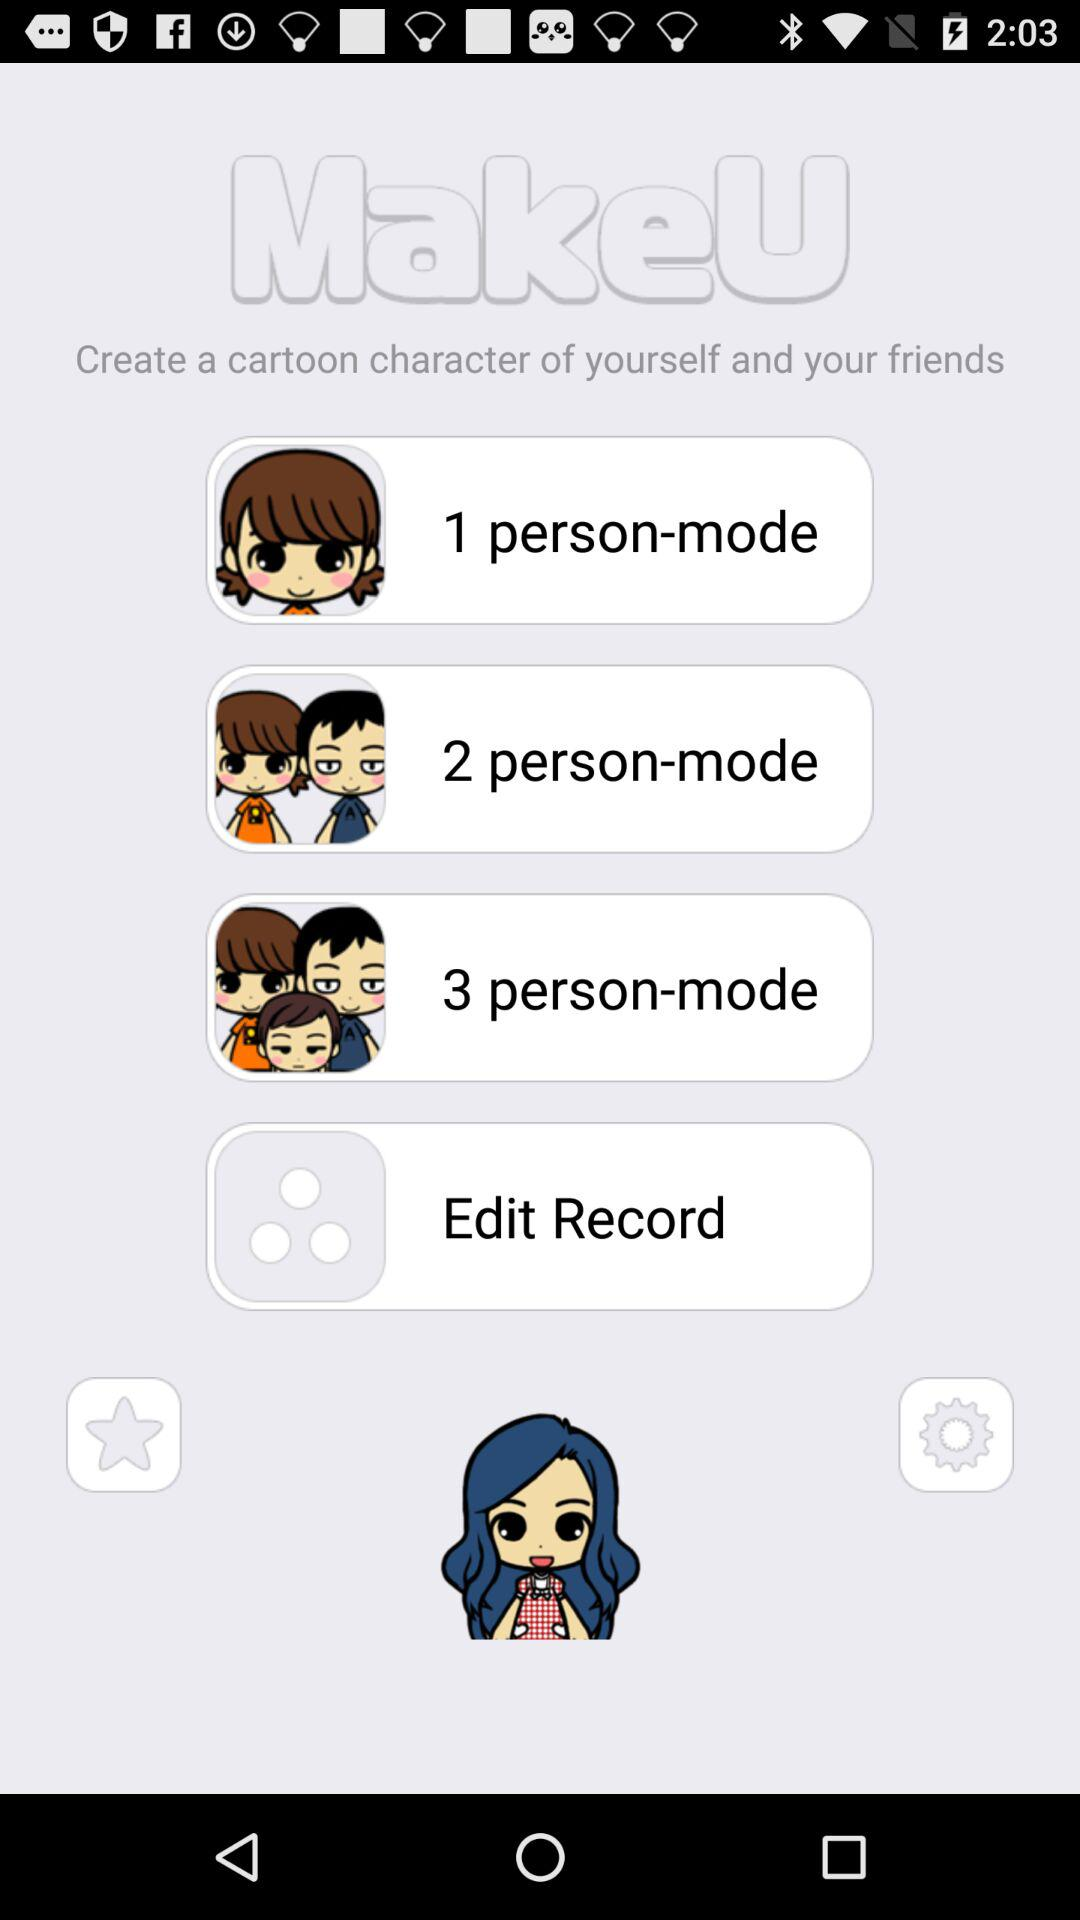What is the application name? The application name is "MakeU". 